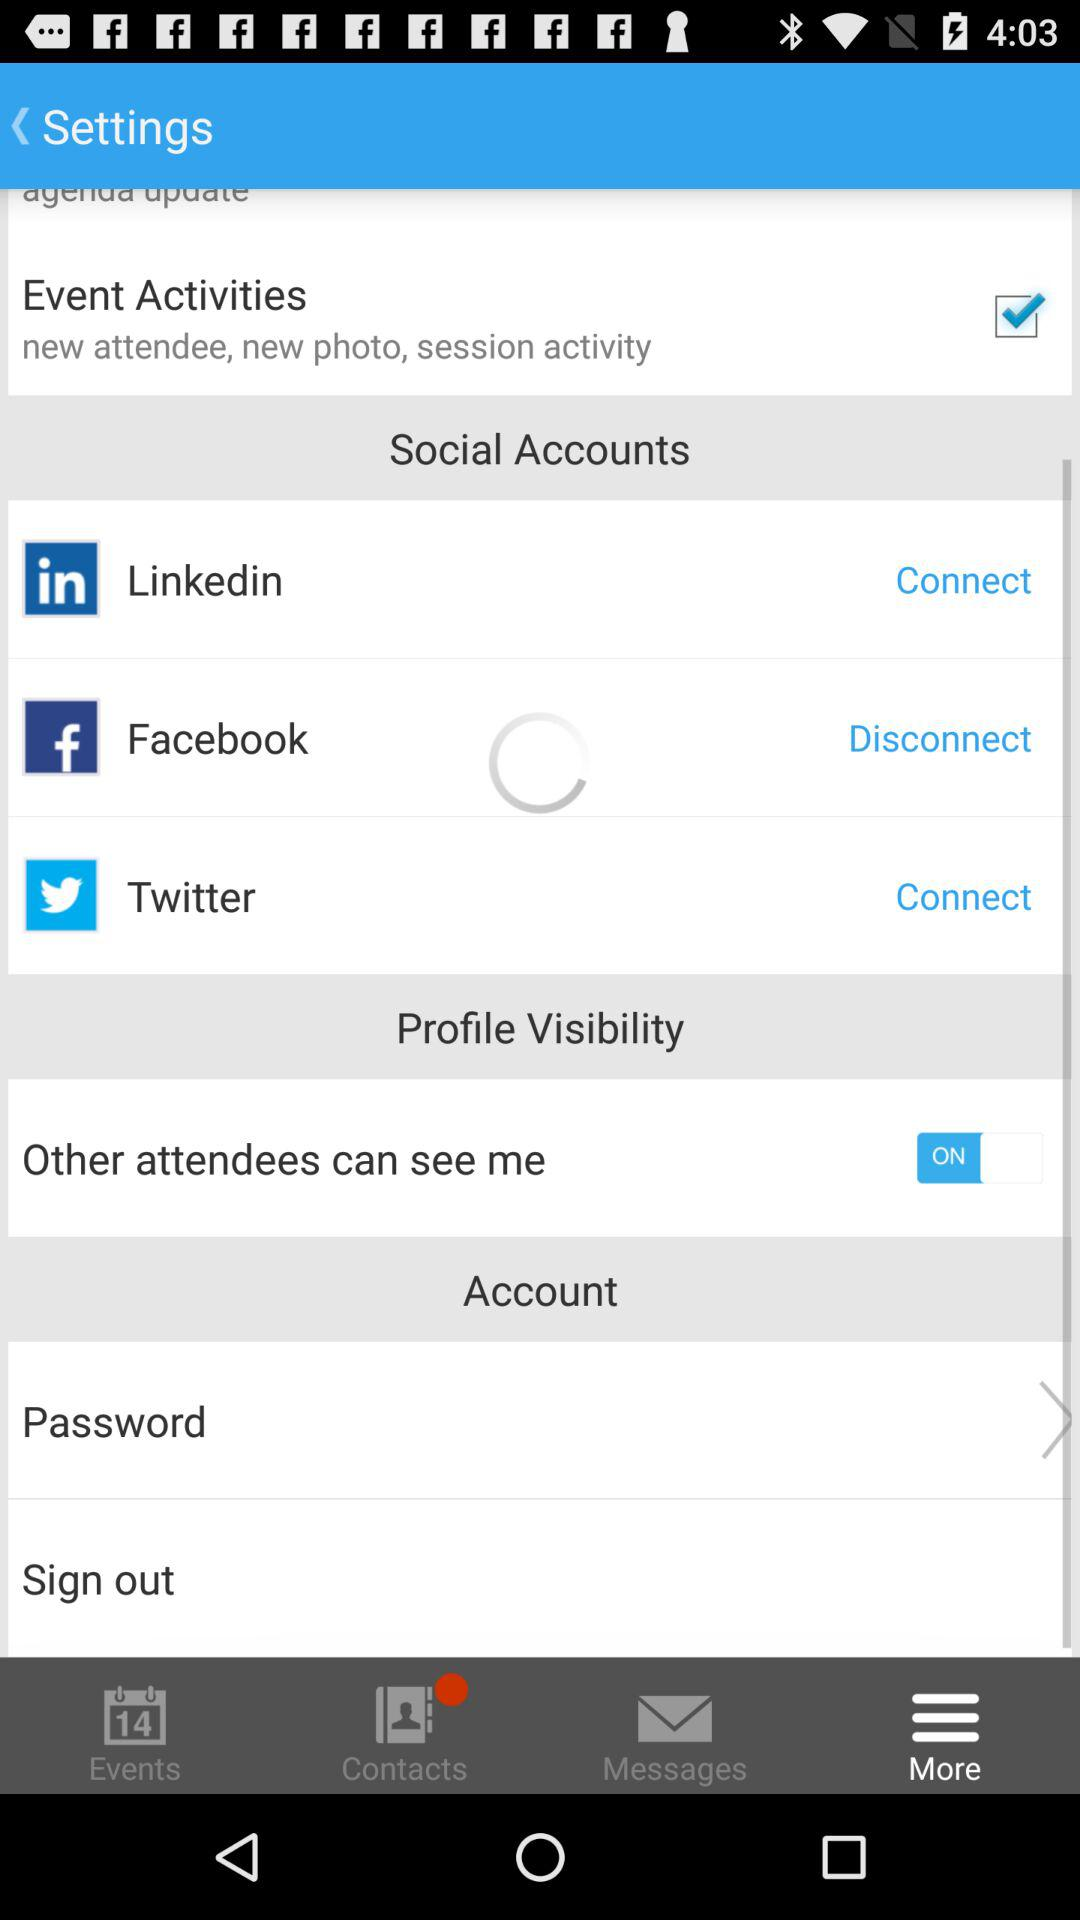Which option is selected? The selected option is "More". 